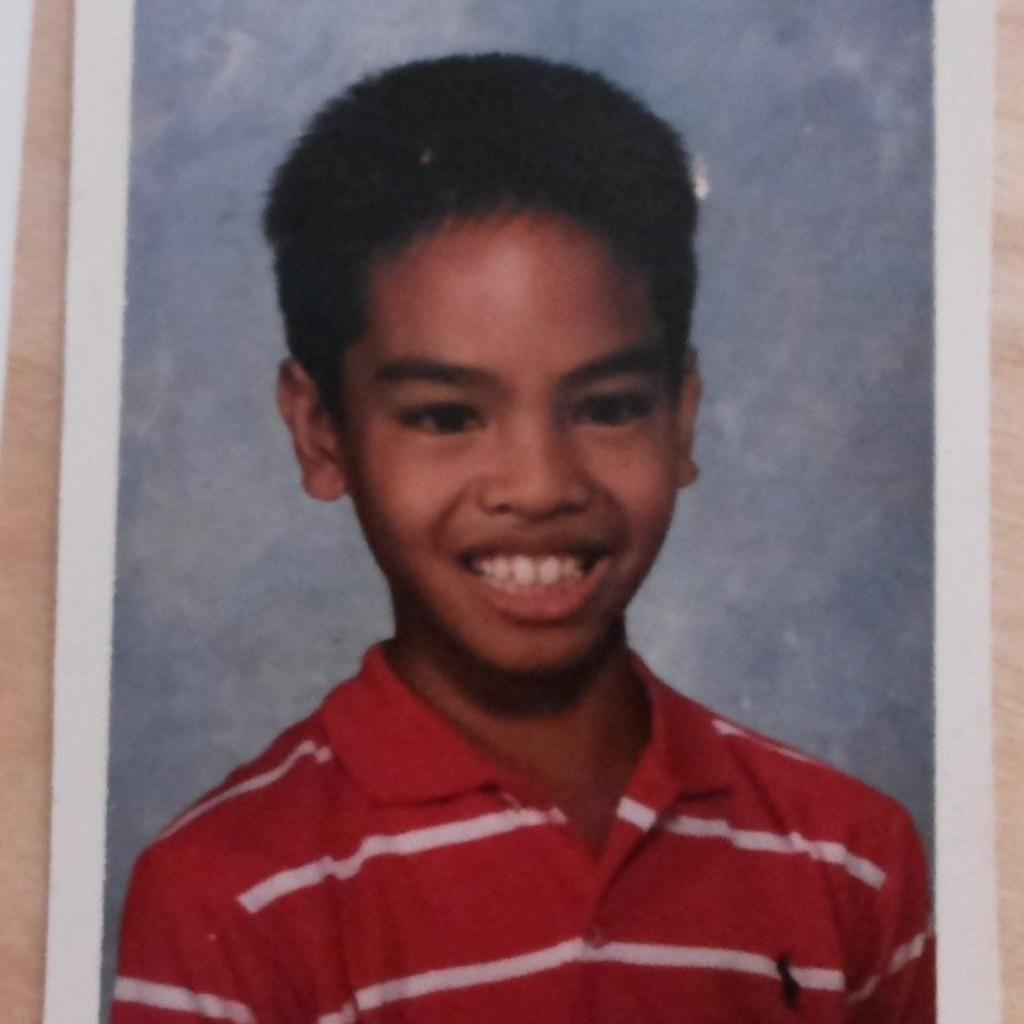What is the main subject of the picture? The main subject of the picture is a boy. What is the boy wearing in the picture? The boy is wearing a red T-shirt. What is the boy's facial expression in the picture? The boy is smiling. What type of bread can be seen in the boy's hand in the image? There is no bread present in the image, and the boy's hands are not visible. 